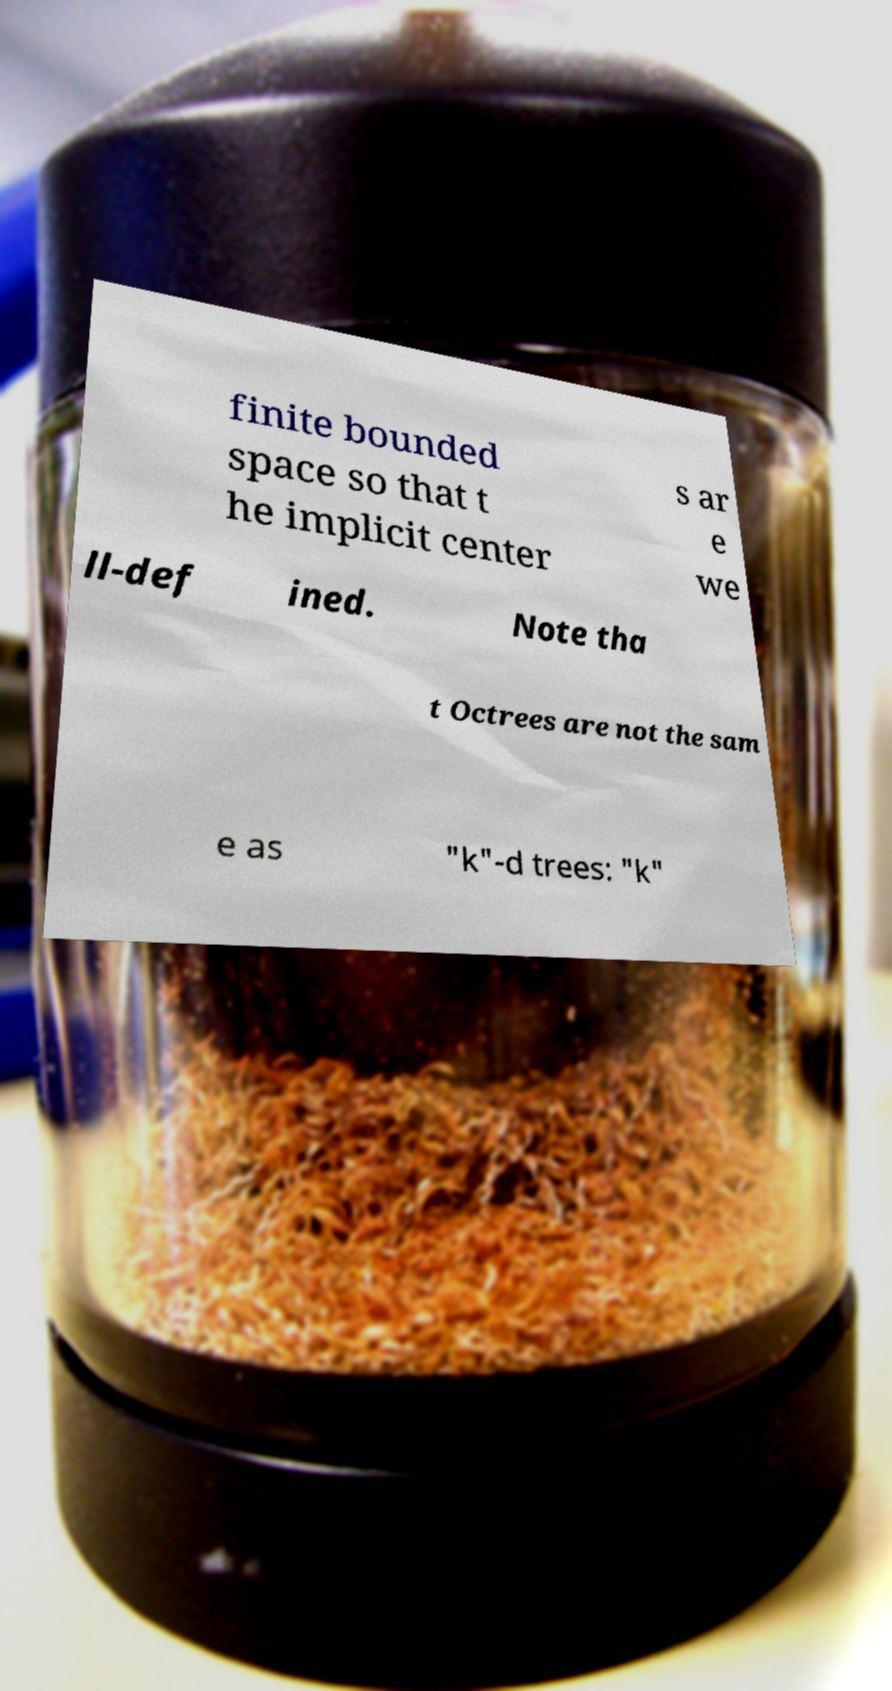There's text embedded in this image that I need extracted. Can you transcribe it verbatim? finite bounded space so that t he implicit center s ar e we ll-def ined. Note tha t Octrees are not the sam e as "k"-d trees: "k" 